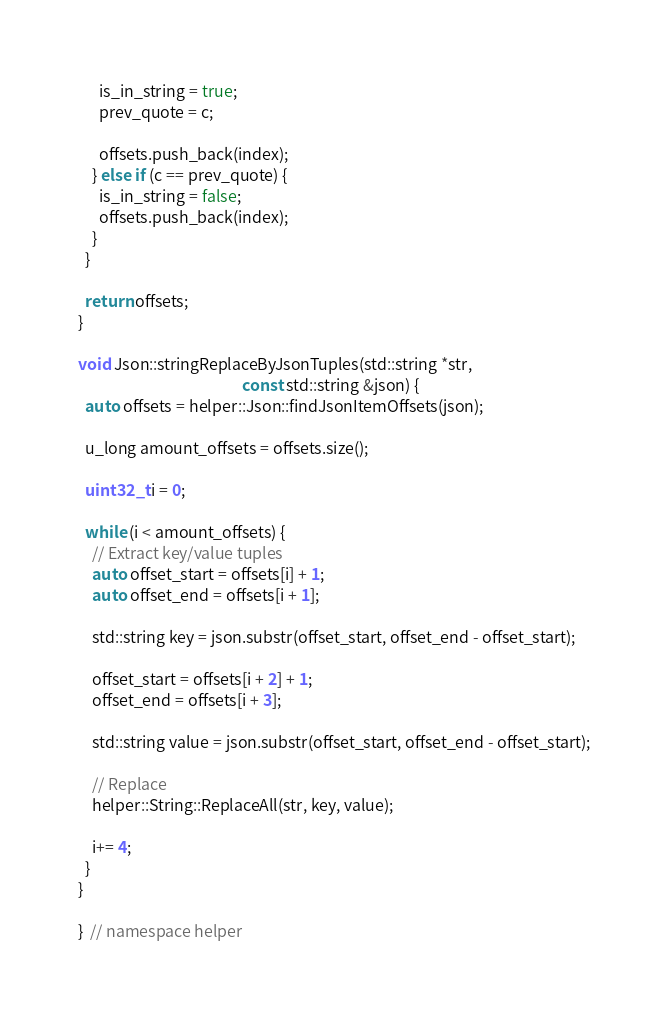<code> <loc_0><loc_0><loc_500><loc_500><_C++_>      is_in_string = true;
      prev_quote = c;

      offsets.push_back(index);
    } else if (c == prev_quote) {
      is_in_string = false;
      offsets.push_back(index);
    }
  }

  return offsets;
}

void Json::stringReplaceByJsonTuples(std::string *str,
                                              const std::string &json) {
  auto offsets = helper::Json::findJsonItemOffsets(json);

  u_long amount_offsets = offsets.size();

  uint32_t i = 0;

  while (i < amount_offsets) {
    // Extract key/value tuples
    auto offset_start = offsets[i] + 1;
    auto offset_end = offsets[i + 1];

    std::string key = json.substr(offset_start, offset_end - offset_start);

    offset_start = offsets[i + 2] + 1;
    offset_end = offsets[i + 3];

    std::string value = json.substr(offset_start, offset_end - offset_start);

    // Replace
    helper::String::ReplaceAll(str, key, value);

    i+= 4;
  }
}

}  // namespace helper
</code> 